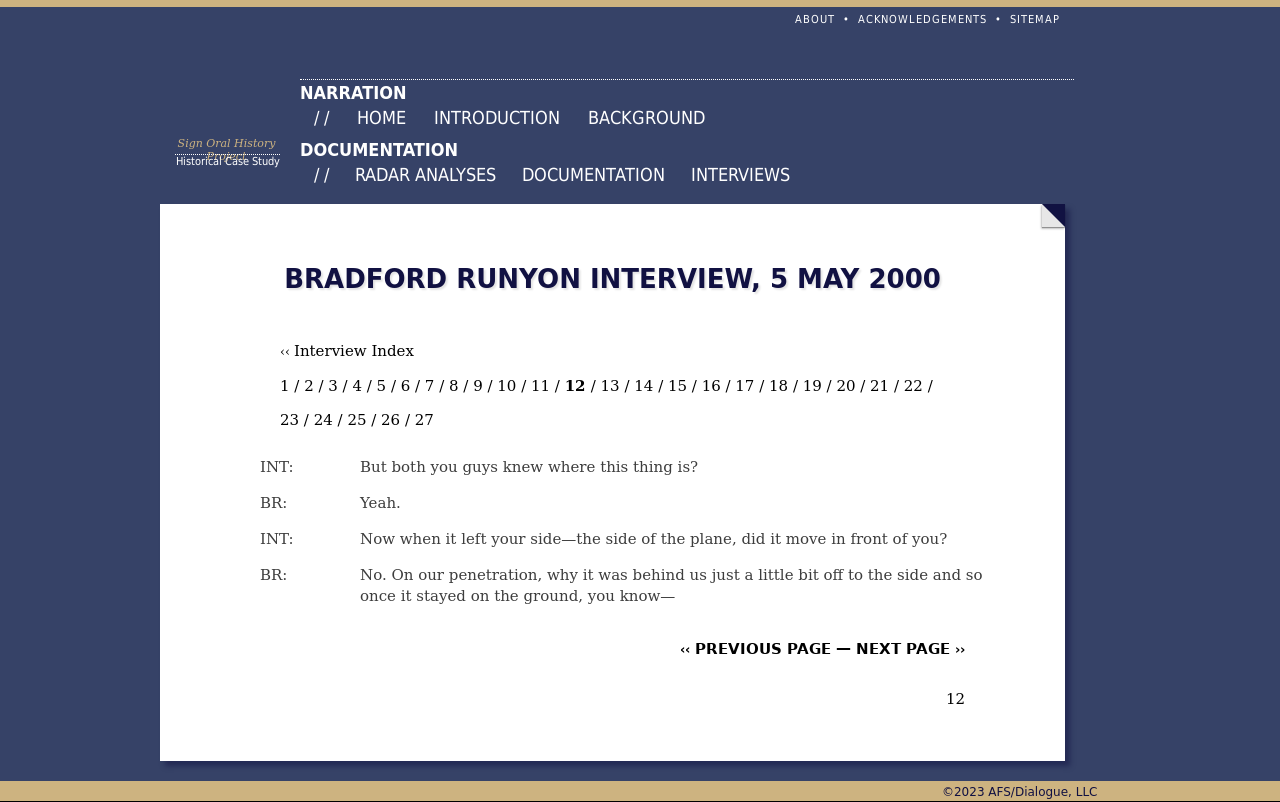What elements on this web page help emphasize the content of the interview displayed? The design elements such as the clear headings, the structured index for navigation through the interview segments, and minimalistic design direct the reader's attention efficiently to the content. The use of a monochrome color scheme with blue accents further ensures that the text stands out without distraction, emphasizing the formal and serious nature of the interview content. 